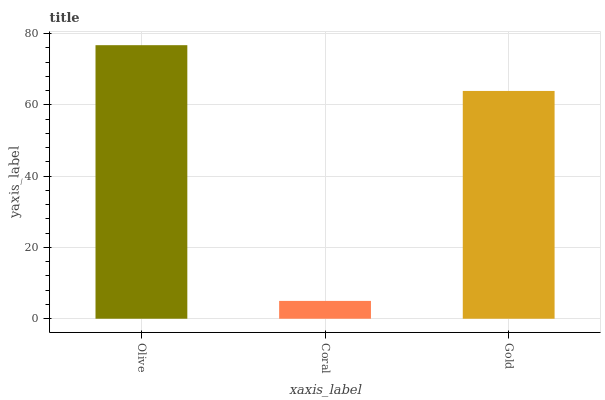Is Coral the minimum?
Answer yes or no. Yes. Is Olive the maximum?
Answer yes or no. Yes. Is Gold the minimum?
Answer yes or no. No. Is Gold the maximum?
Answer yes or no. No. Is Gold greater than Coral?
Answer yes or no. Yes. Is Coral less than Gold?
Answer yes or no. Yes. Is Coral greater than Gold?
Answer yes or no. No. Is Gold less than Coral?
Answer yes or no. No. Is Gold the high median?
Answer yes or no. Yes. Is Gold the low median?
Answer yes or no. Yes. Is Olive the high median?
Answer yes or no. No. Is Olive the low median?
Answer yes or no. No. 